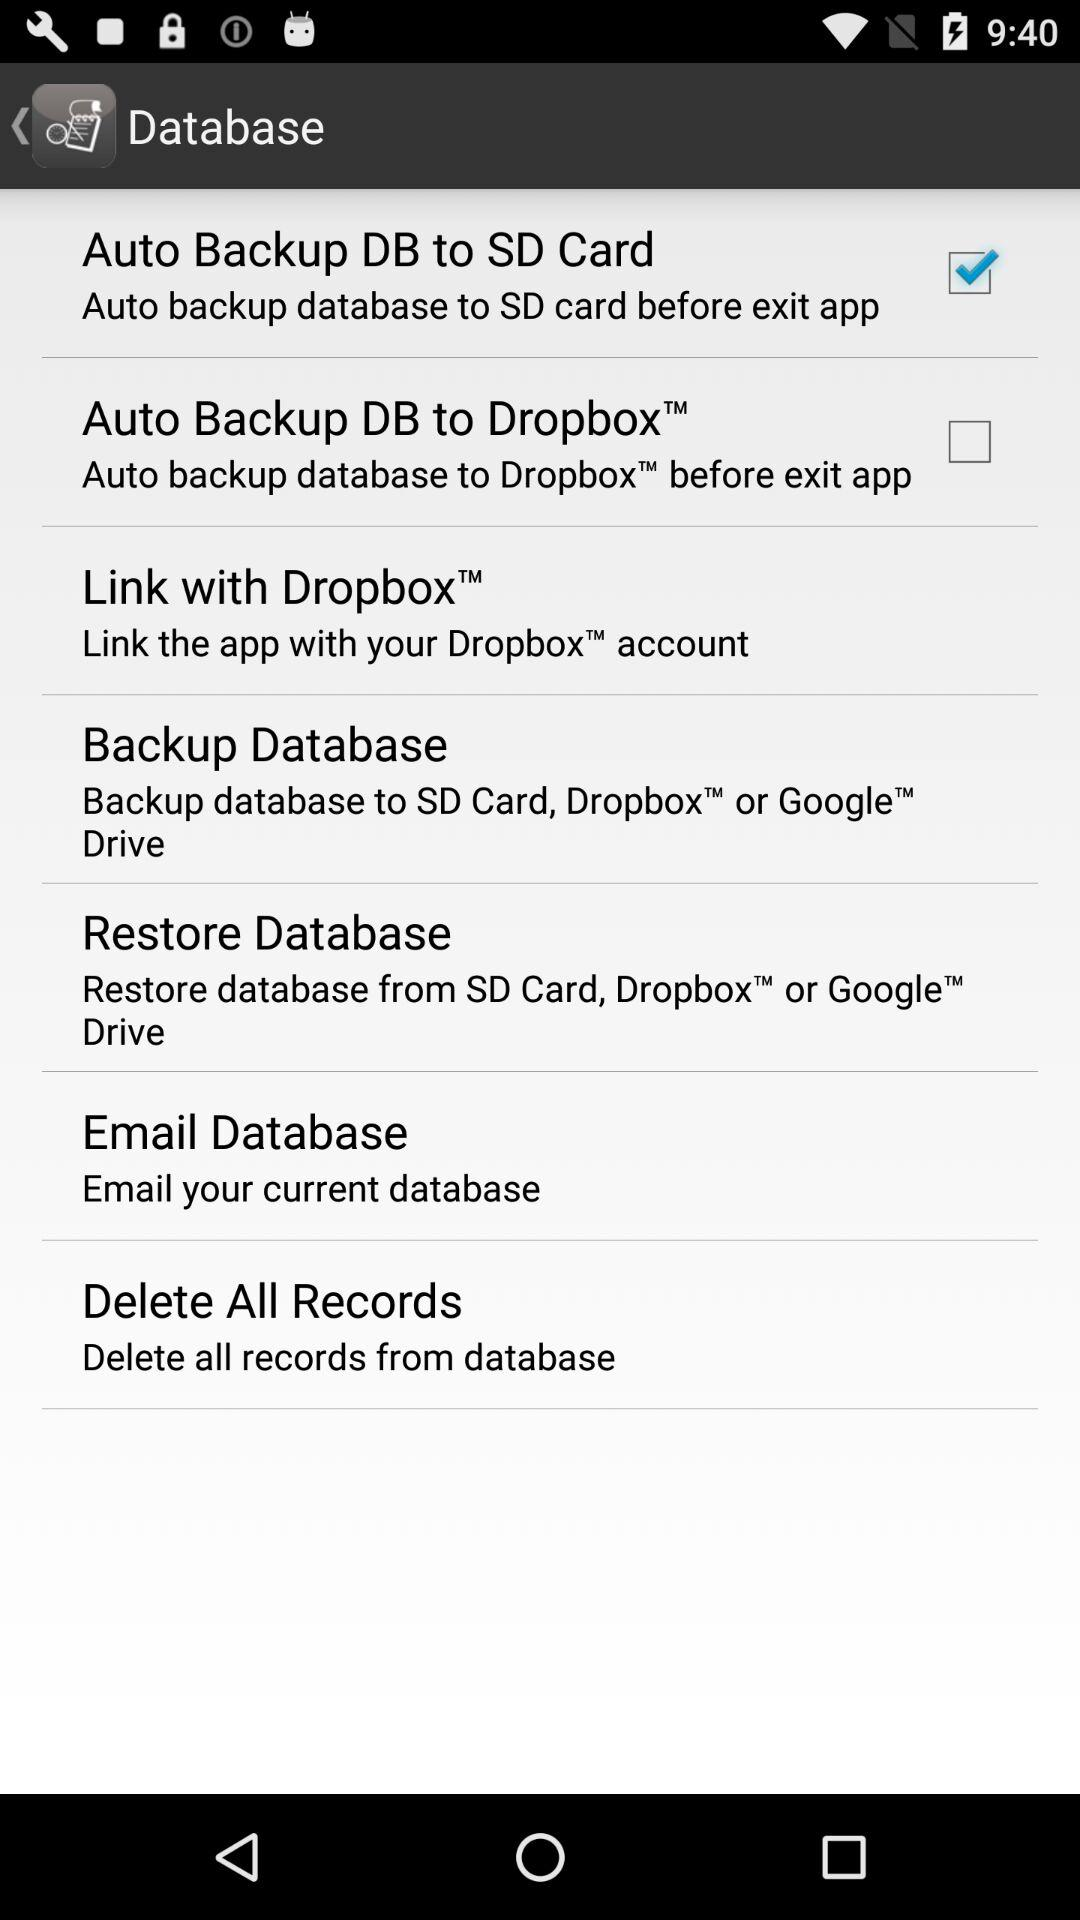Where can I back up the database? You can backup your database to SD card, Dropbox, or Google Drive. 